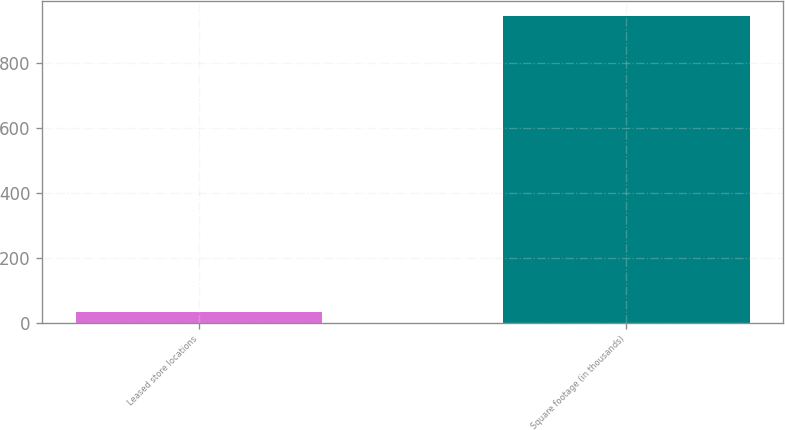Convert chart. <chart><loc_0><loc_0><loc_500><loc_500><bar_chart><fcel>Leased store locations<fcel>Square footage (in thousands)<nl><fcel>35<fcel>944<nl></chart> 